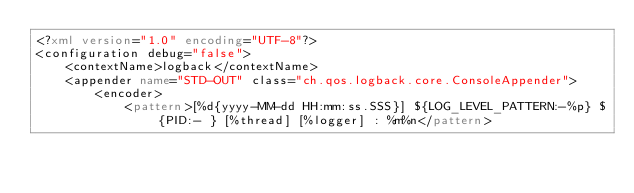<code> <loc_0><loc_0><loc_500><loc_500><_XML_><?xml version="1.0" encoding="UTF-8"?>
<configuration debug="false">
    <contextName>logback</contextName>
    <appender name="STD-OUT" class="ch.qos.logback.core.ConsoleAppender">
        <encoder>
            <pattern>[%d{yyyy-MM-dd HH:mm:ss.SSS}] ${LOG_LEVEL_PATTERN:-%p} ${PID:- } [%thread] [%logger] : %m%n</pattern></code> 